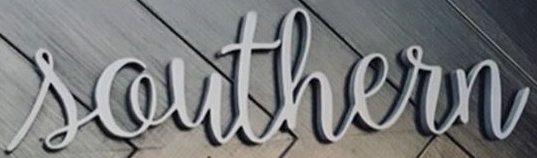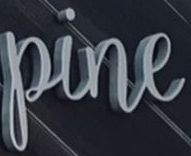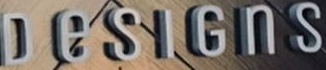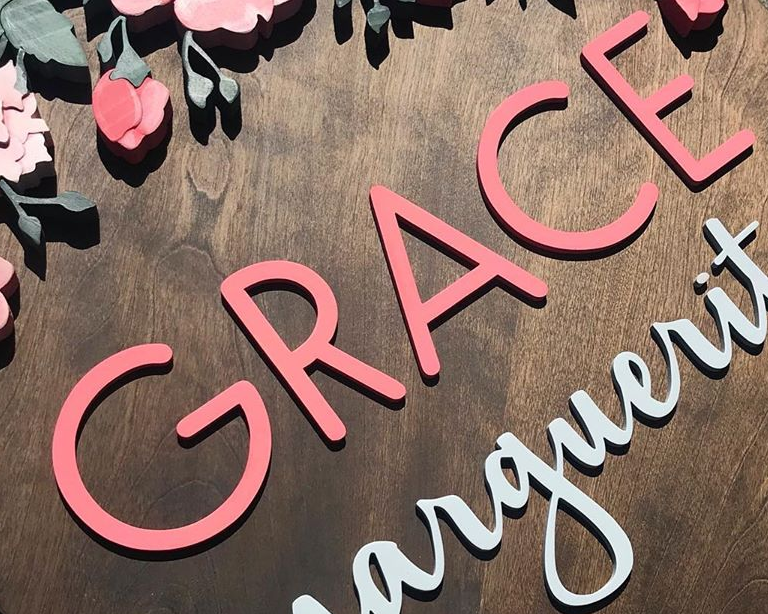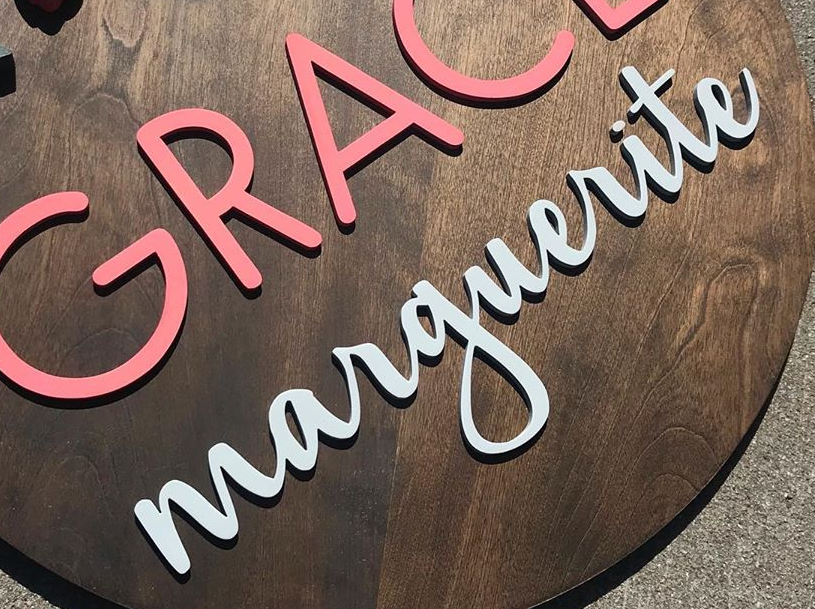Read the text content from these images in order, separated by a semicolon. Southern; pine; DeSIGnS; GRACE; marguerite 